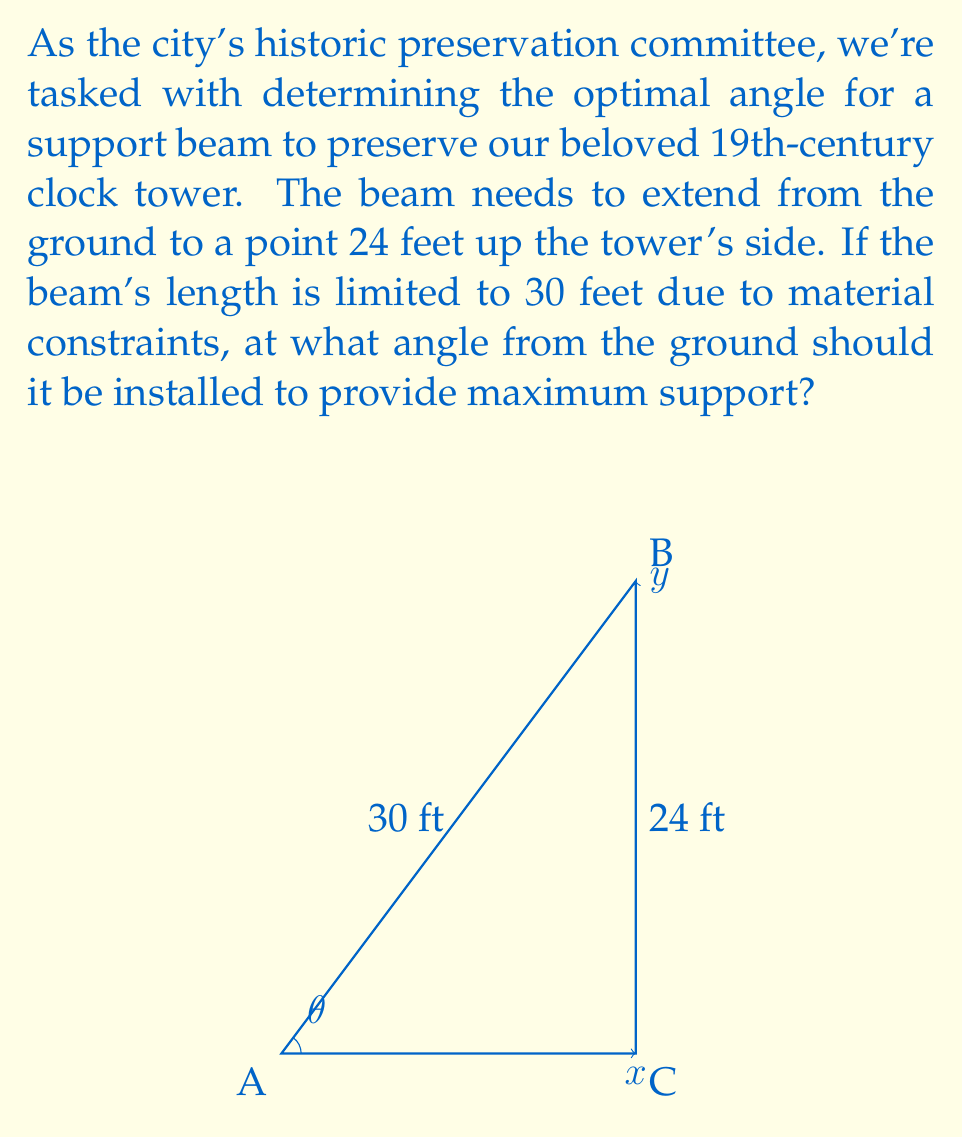Provide a solution to this math problem. Let's approach this step-by-step:

1) We can use the Pythagorean theorem to set up our equation. Let $x$ be the horizontal distance from the base of the tower to where the beam meets the ground.

   $$x^2 + 24^2 = 30^2$$

2) Solve for $x$:
   $$x^2 = 30^2 - 24^2 = 900 - 576 = 324$$
   $$x = \sqrt{324} = 18$$

3) Now we have a right triangle with sides 18, 24, and 30.

4) To find the angle $\theta$, we can use the inverse sine function (arcsin):

   $$\theta = \arcsin(\frac{\text{opposite}}{\text{hypotenuse}}) = \arcsin(\frac{24}{30})$$

5) Simplify the fraction inside arcsin:
   $$\theta = \arcsin(\frac{4}{5})$$

6) Calculate:
   $$\theta \approx 53.13^\circ$$

This angle will provide the optimal support for the historic clock tower given the constraints.
Answer: $\arcsin(\frac{4}{5}) \approx 53.13^\circ$ 